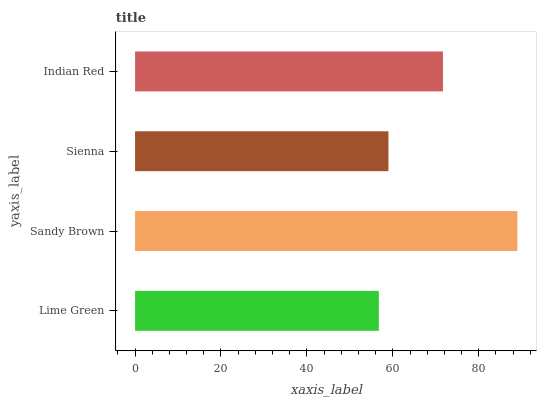Is Lime Green the minimum?
Answer yes or no. Yes. Is Sandy Brown the maximum?
Answer yes or no. Yes. Is Sienna the minimum?
Answer yes or no. No. Is Sienna the maximum?
Answer yes or no. No. Is Sandy Brown greater than Sienna?
Answer yes or no. Yes. Is Sienna less than Sandy Brown?
Answer yes or no. Yes. Is Sienna greater than Sandy Brown?
Answer yes or no. No. Is Sandy Brown less than Sienna?
Answer yes or no. No. Is Indian Red the high median?
Answer yes or no. Yes. Is Sienna the low median?
Answer yes or no. Yes. Is Lime Green the high median?
Answer yes or no. No. Is Sandy Brown the low median?
Answer yes or no. No. 